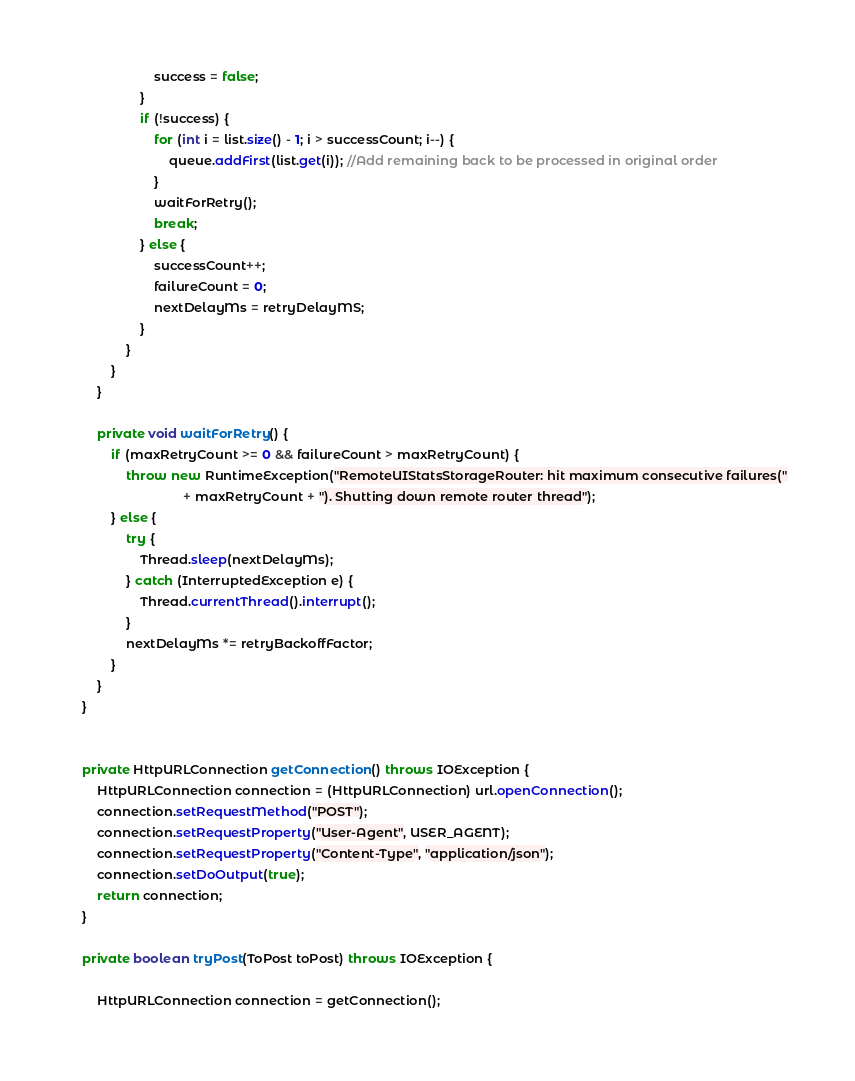Convert code to text. <code><loc_0><loc_0><loc_500><loc_500><_Java_>                        success = false;
                    }
                    if (!success) {
                        for (int i = list.size() - 1; i > successCount; i--) {
                            queue.addFirst(list.get(i)); //Add remaining back to be processed in original order
                        }
                        waitForRetry();
                        break;
                    } else {
                        successCount++;
                        failureCount = 0;
                        nextDelayMs = retryDelayMS;
                    }
                }
            }
        }

        private void waitForRetry() {
            if (maxRetryCount >= 0 && failureCount > maxRetryCount) {
                throw new RuntimeException("RemoteUIStatsStorageRouter: hit maximum consecutive failures("
                                + maxRetryCount + "). Shutting down remote router thread");
            } else {
                try {
                    Thread.sleep(nextDelayMs);
                } catch (InterruptedException e) {
                    Thread.currentThread().interrupt();
                }
                nextDelayMs *= retryBackoffFactor;
            }
        }
    }


    private HttpURLConnection getConnection() throws IOException {
        HttpURLConnection connection = (HttpURLConnection) url.openConnection();
        connection.setRequestMethod("POST");
        connection.setRequestProperty("User-Agent", USER_AGENT);
        connection.setRequestProperty("Content-Type", "application/json");
        connection.setDoOutput(true);
        return connection;
    }

    private boolean tryPost(ToPost toPost) throws IOException {

        HttpURLConnection connection = getConnection();
</code> 